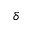<formula> <loc_0><loc_0><loc_500><loc_500>\delta</formula> 